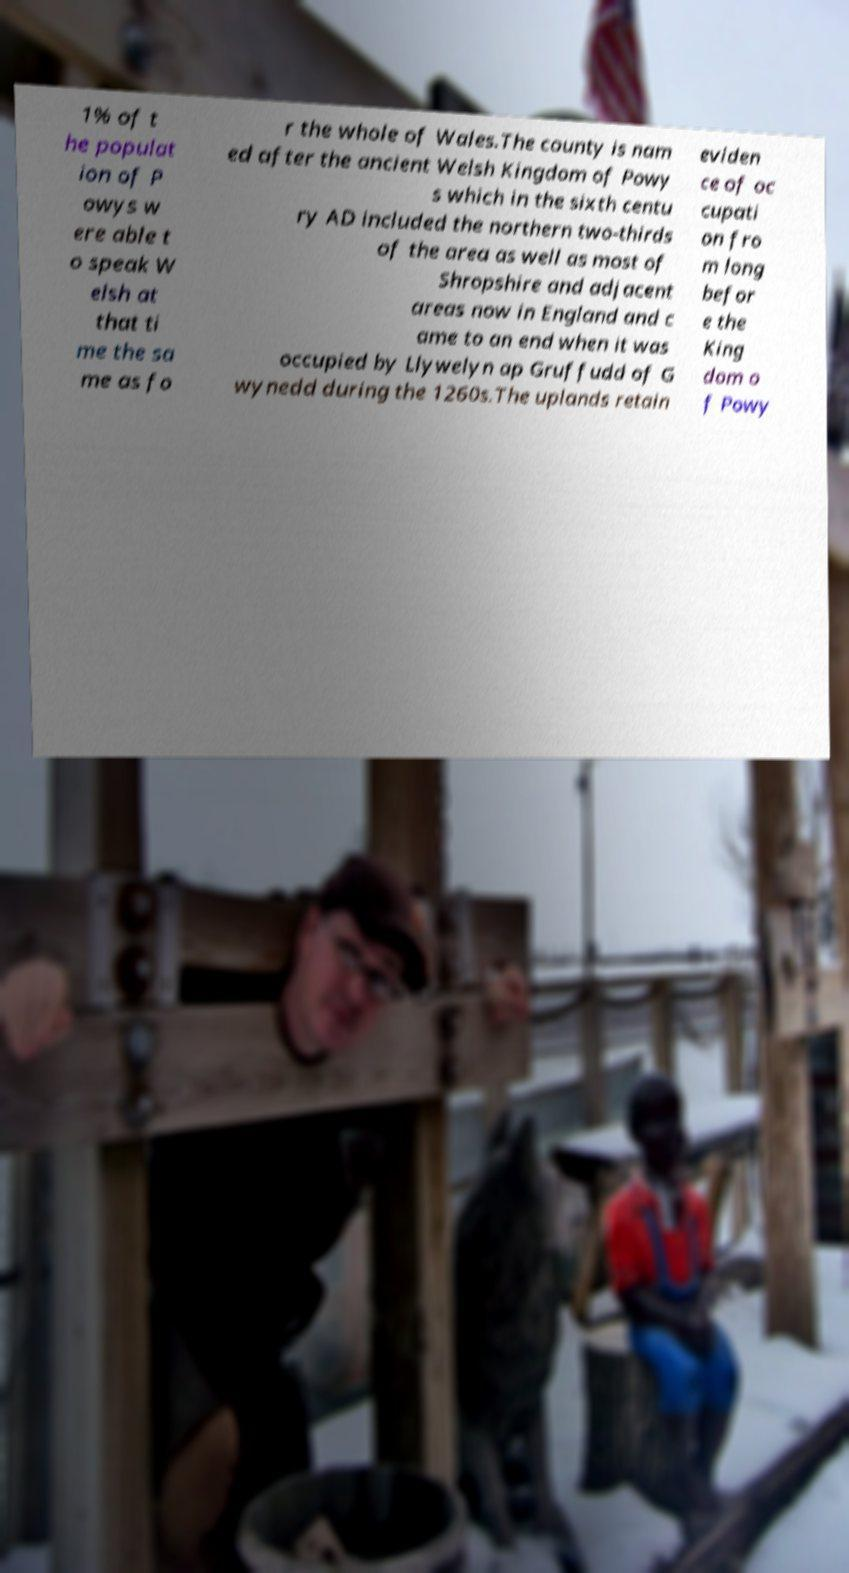Can you accurately transcribe the text from the provided image for me? 1% of t he populat ion of P owys w ere able t o speak W elsh at that ti me the sa me as fo r the whole of Wales.The county is nam ed after the ancient Welsh Kingdom of Powy s which in the sixth centu ry AD included the northern two-thirds of the area as well as most of Shropshire and adjacent areas now in England and c ame to an end when it was occupied by Llywelyn ap Gruffudd of G wynedd during the 1260s.The uplands retain eviden ce of oc cupati on fro m long befor e the King dom o f Powy 